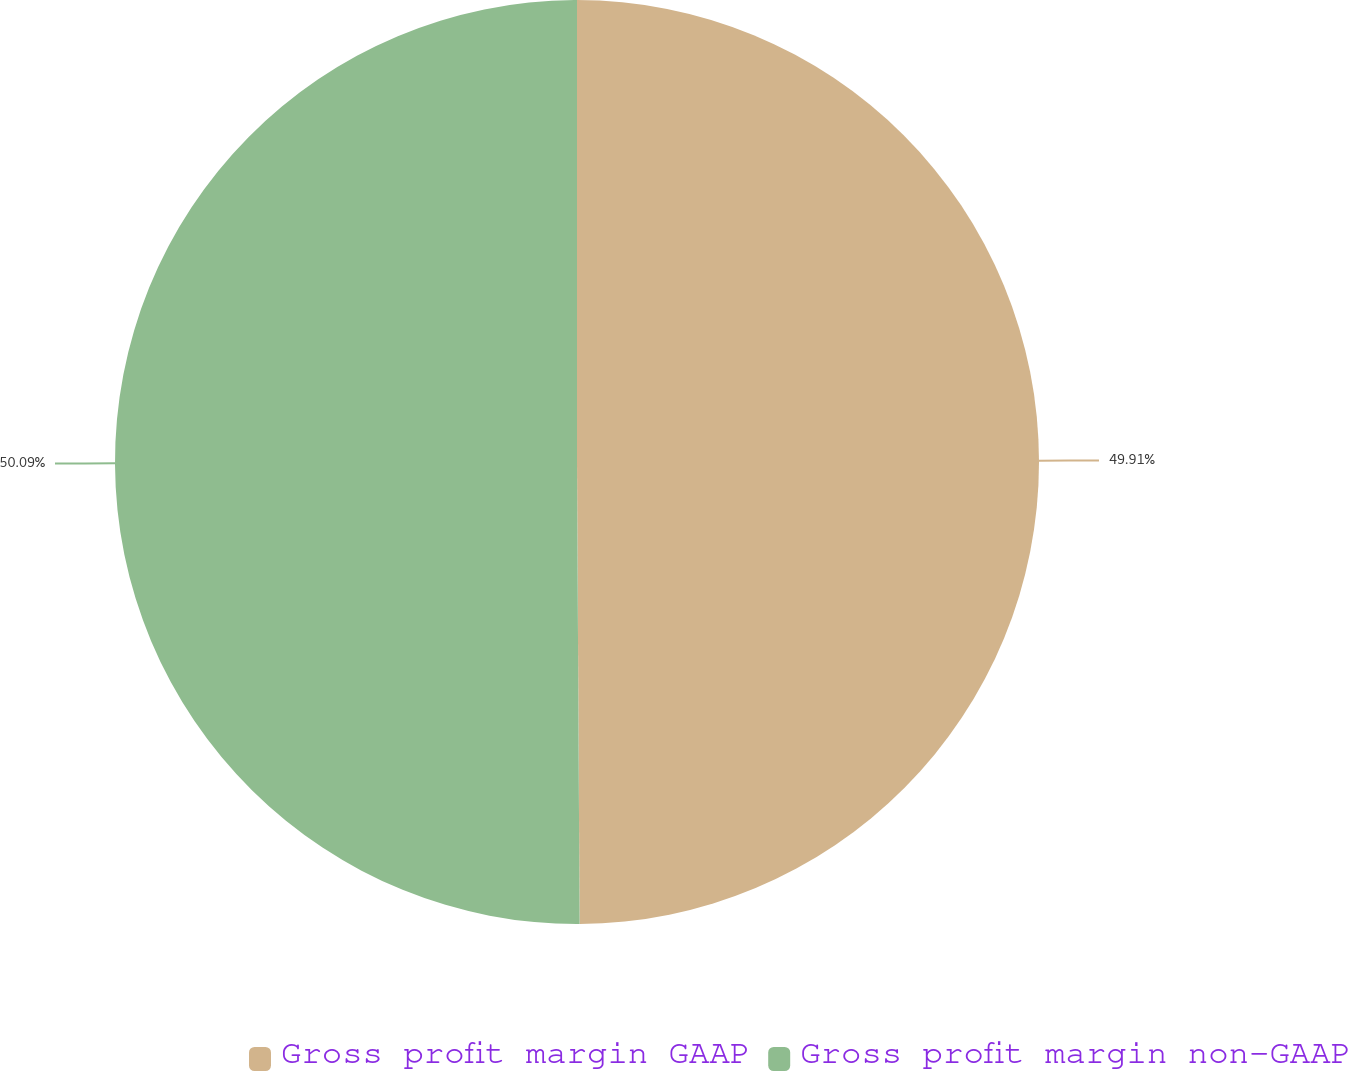Convert chart to OTSL. <chart><loc_0><loc_0><loc_500><loc_500><pie_chart><fcel>Gross profit margin GAAP<fcel>Gross profit margin non-GAAP<nl><fcel>49.91%<fcel>50.09%<nl></chart> 